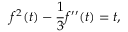<formula> <loc_0><loc_0><loc_500><loc_500>f ^ { 2 } ( t ) - { \frac { 1 } { 3 } } f ^ { \prime \prime } ( t ) = t ,</formula> 